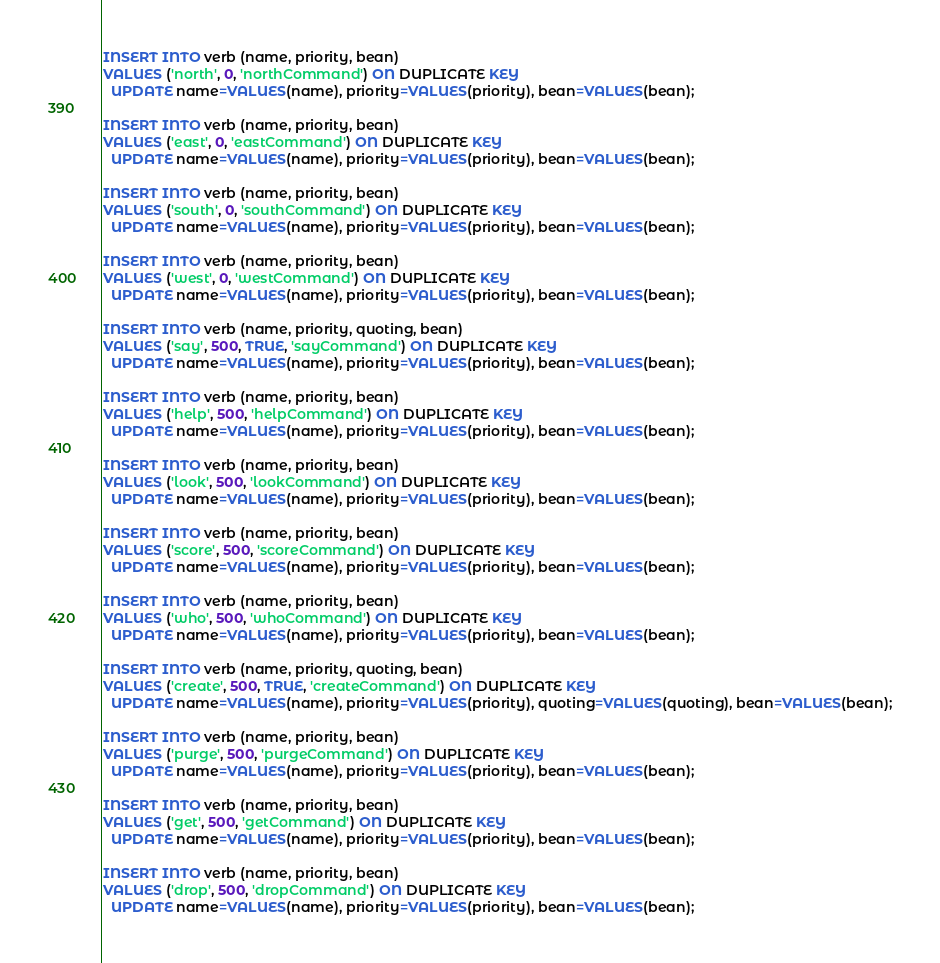Convert code to text. <code><loc_0><loc_0><loc_500><loc_500><_SQL_>INSERT INTO verb (name, priority, bean)
VALUES ('north', 0, 'northCommand') ON DUPLICATE KEY
  UPDATE name=VALUES(name), priority=VALUES(priority), bean=VALUES(bean);

INSERT INTO verb (name, priority, bean)
VALUES ('east', 0, 'eastCommand') ON DUPLICATE KEY
  UPDATE name=VALUES(name), priority=VALUES(priority), bean=VALUES(bean);

INSERT INTO verb (name, priority, bean)
VALUES ('south', 0, 'southCommand') ON DUPLICATE KEY
  UPDATE name=VALUES(name), priority=VALUES(priority), bean=VALUES(bean);

INSERT INTO verb (name, priority, bean)
VALUES ('west', 0, 'westCommand') ON DUPLICATE KEY
  UPDATE name=VALUES(name), priority=VALUES(priority), bean=VALUES(bean);

INSERT INTO verb (name, priority, quoting, bean)
VALUES ('say', 500, TRUE, 'sayCommand') ON DUPLICATE KEY
  UPDATE name=VALUES(name), priority=VALUES(priority), bean=VALUES(bean);

INSERT INTO verb (name, priority, bean)
VALUES ('help', 500, 'helpCommand') ON DUPLICATE KEY
  UPDATE name=VALUES(name), priority=VALUES(priority), bean=VALUES(bean);

INSERT INTO verb (name, priority, bean)
VALUES ('look', 500, 'lookCommand') ON DUPLICATE KEY
  UPDATE name=VALUES(name), priority=VALUES(priority), bean=VALUES(bean);

INSERT INTO verb (name, priority, bean)
VALUES ('score', 500, 'scoreCommand') ON DUPLICATE KEY
  UPDATE name=VALUES(name), priority=VALUES(priority), bean=VALUES(bean);

INSERT INTO verb (name, priority, bean)
VALUES ('who', 500, 'whoCommand') ON DUPLICATE KEY
  UPDATE name=VALUES(name), priority=VALUES(priority), bean=VALUES(bean);

INSERT INTO verb (name, priority, quoting, bean)
VALUES ('create', 500, TRUE, 'createCommand') ON DUPLICATE KEY
  UPDATE name=VALUES(name), priority=VALUES(priority), quoting=VALUES(quoting), bean=VALUES(bean);

INSERT INTO verb (name, priority, bean)
VALUES ('purge', 500, 'purgeCommand') ON DUPLICATE KEY
  UPDATE name=VALUES(name), priority=VALUES(priority), bean=VALUES(bean);

INSERT INTO verb (name, priority, bean)
VALUES ('get', 500, 'getCommand') ON DUPLICATE KEY
  UPDATE name=VALUES(name), priority=VALUES(priority), bean=VALUES(bean);

INSERT INTO verb (name, priority, bean)
VALUES ('drop', 500, 'dropCommand') ON DUPLICATE KEY
  UPDATE name=VALUES(name), priority=VALUES(priority), bean=VALUES(bean);
</code> 